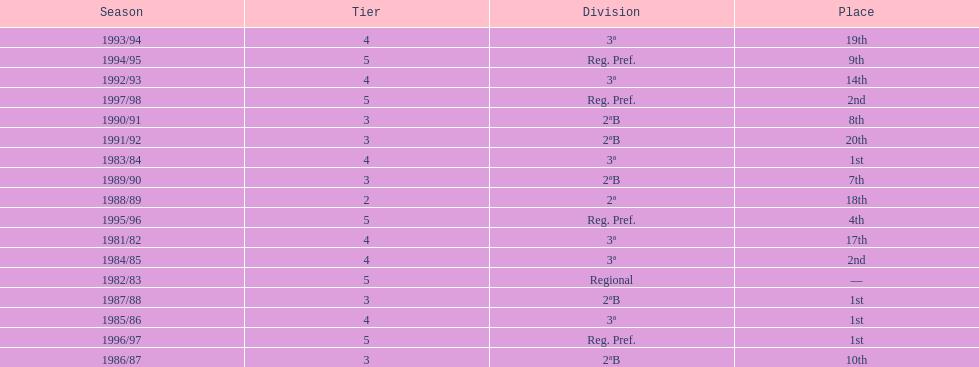How many years were they in tier 3 5. 